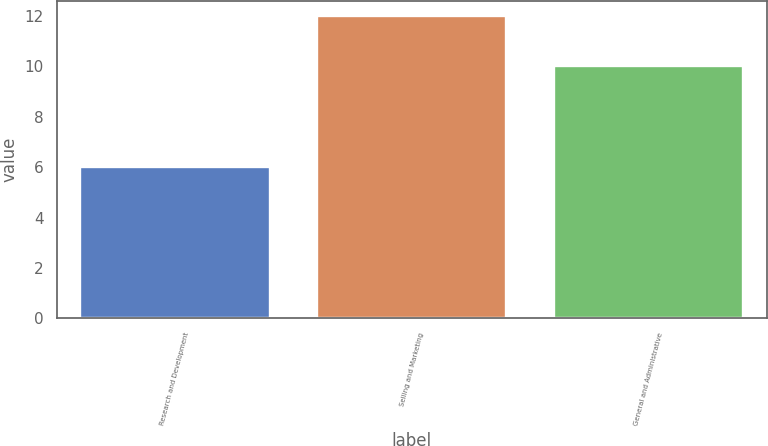Convert chart. <chart><loc_0><loc_0><loc_500><loc_500><bar_chart><fcel>Research and Development<fcel>Selling and Marketing<fcel>General and Administrative<nl><fcel>6<fcel>12<fcel>10<nl></chart> 